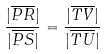<formula> <loc_0><loc_0><loc_500><loc_500>\frac { | \overline { P R } | } { | \overline { P S } | } = \frac { | \overline { T V } | } { | \overline { T U } | }</formula> 